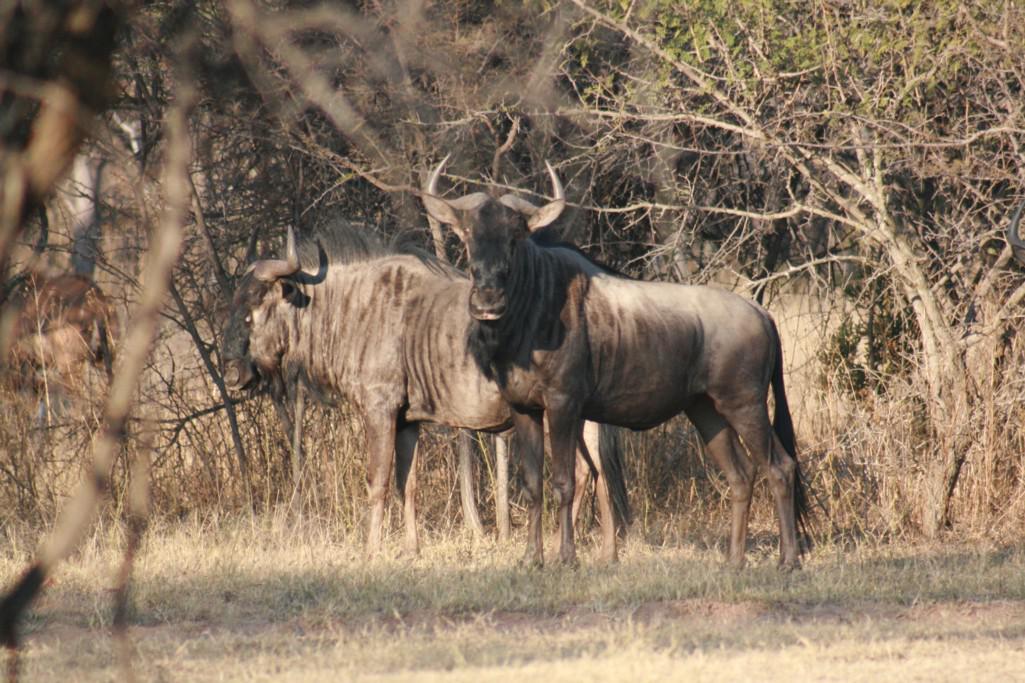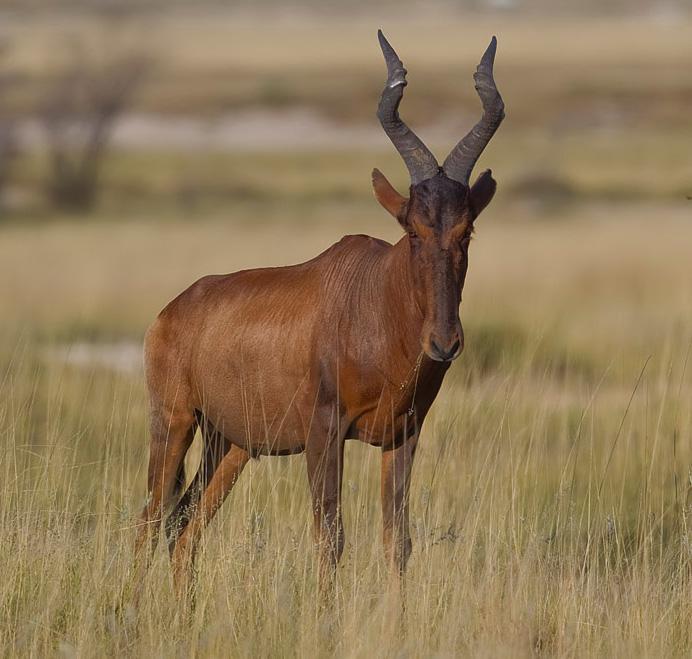The first image is the image on the left, the second image is the image on the right. For the images shown, is this caption "There are more hooved, horned animals on the right than on the left." true? Answer yes or no. No. 